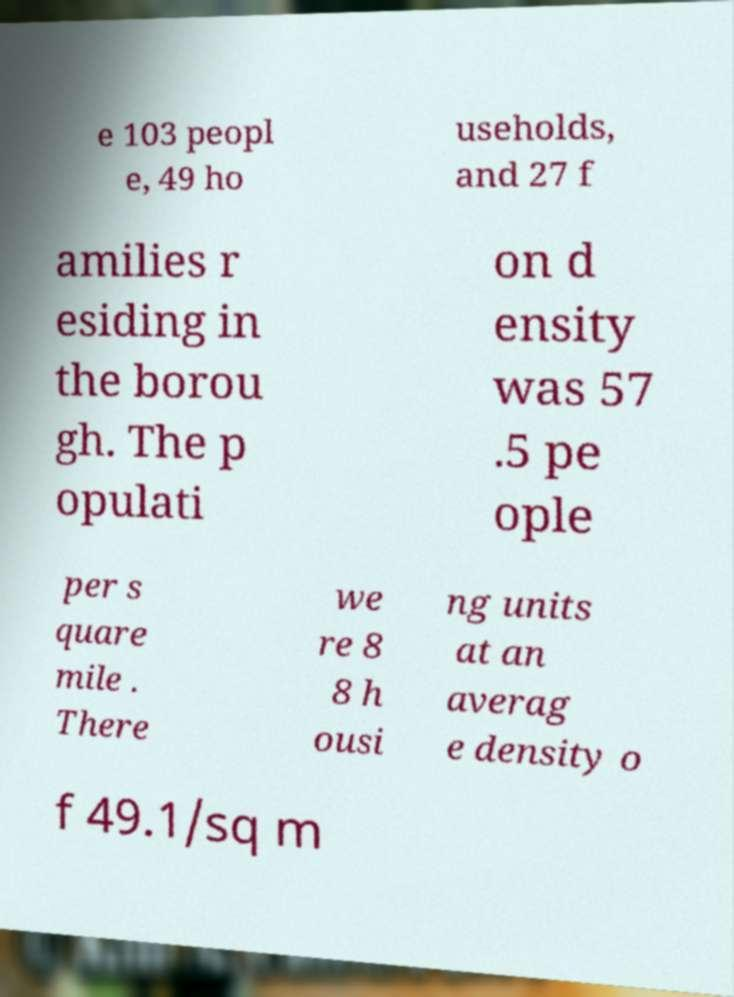There's text embedded in this image that I need extracted. Can you transcribe it verbatim? e 103 peopl e, 49 ho useholds, and 27 f amilies r esiding in the borou gh. The p opulati on d ensity was 57 .5 pe ople per s quare mile . There we re 8 8 h ousi ng units at an averag e density o f 49.1/sq m 